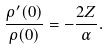Convert formula to latex. <formula><loc_0><loc_0><loc_500><loc_500>\frac { \rho ^ { \prime } ( 0 ) } { \rho ( 0 ) } = - \frac { 2 Z } { \alpha } .</formula> 